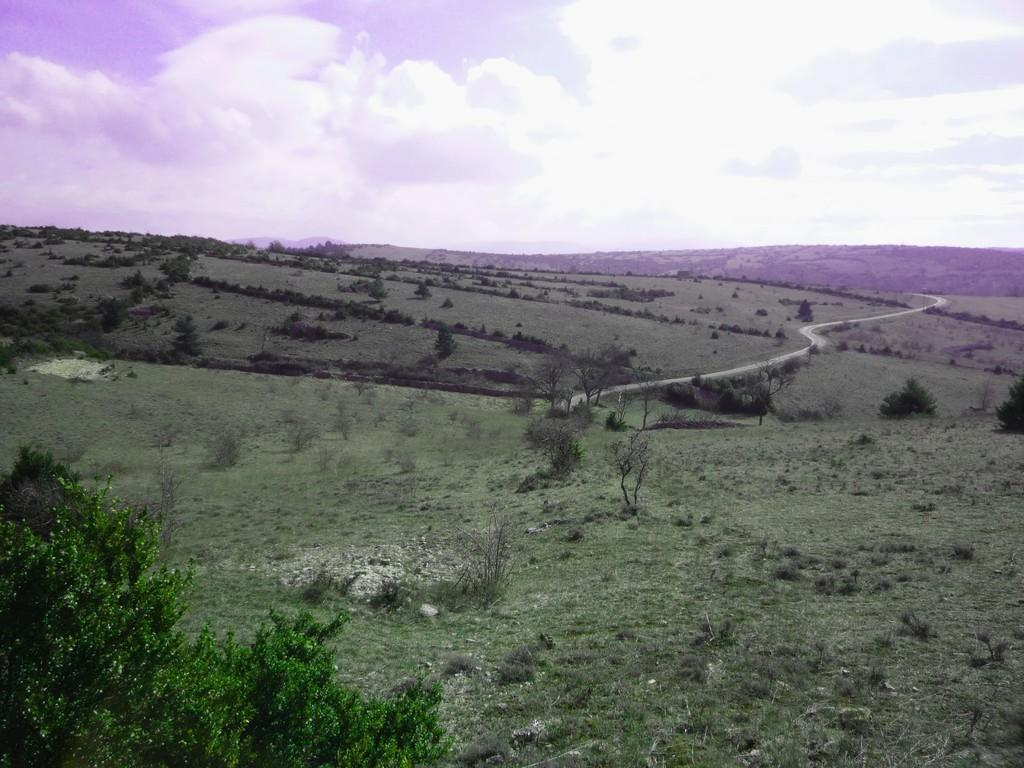What type of vegetation can be seen in the image? There is grass and a plant in the image. What kind of surface is visible in the image? There is a path in the image. What is visible in the sky in the image? The sky is visible in the image and appears cloudy. Can you read the note that is attached to the plant in the image? There is no note attached to the plant in the image. How many snakes can be seen slithering on the path in the image? There are no snakes present in the image. 